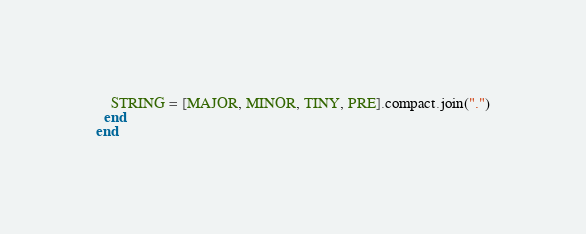Convert code to text. <code><loc_0><loc_0><loc_500><loc_500><_Ruby_>
    STRING = [MAJOR, MINOR, TINY, PRE].compact.join(".")
  end
end
</code> 